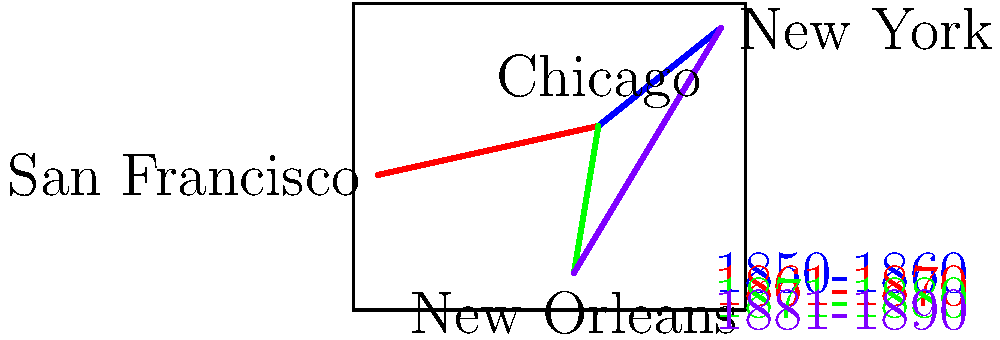Based on the map showing the expansion of railroads in the United States during the 19th century, which city appears to have become the most significant railroad hub, connecting to all other major cities shown? To determine the most significant railroad hub, we need to analyze the connections between the cities shown on the map:

1. Identify the cities: Chicago, New York, San Francisco, and New Orleans.

2. Examine the railroad connections:
   - Chicago to New York (blue line, 1850-1860)
   - Chicago to San Francisco (red line, 1861-1870)
   - Chicago to New Orleans (green line, 1871-1880)
   - New York to New Orleans (purple line, 1881-1890)

3. Count the connections for each city:
   - Chicago: 3 connections (to New York, San Francisco, and New Orleans)
   - New York: 2 connections (to Chicago and New Orleans)
   - San Francisco: 1 connection (to Chicago)
   - New Orleans: 2 connections (to Chicago and New York)

4. Analyze the results:
   Chicago has the most connections (3) and is the only city connected to all other cities shown on the map.

5. Consider the historical context:
   Chicago's central location made it an ideal hub for connecting the East Coast (New York) to the West Coast (San Francisco) and the South (New Orleans).

Based on this analysis, Chicago emerges as the most significant railroad hub among the cities shown on the map.
Answer: Chicago 